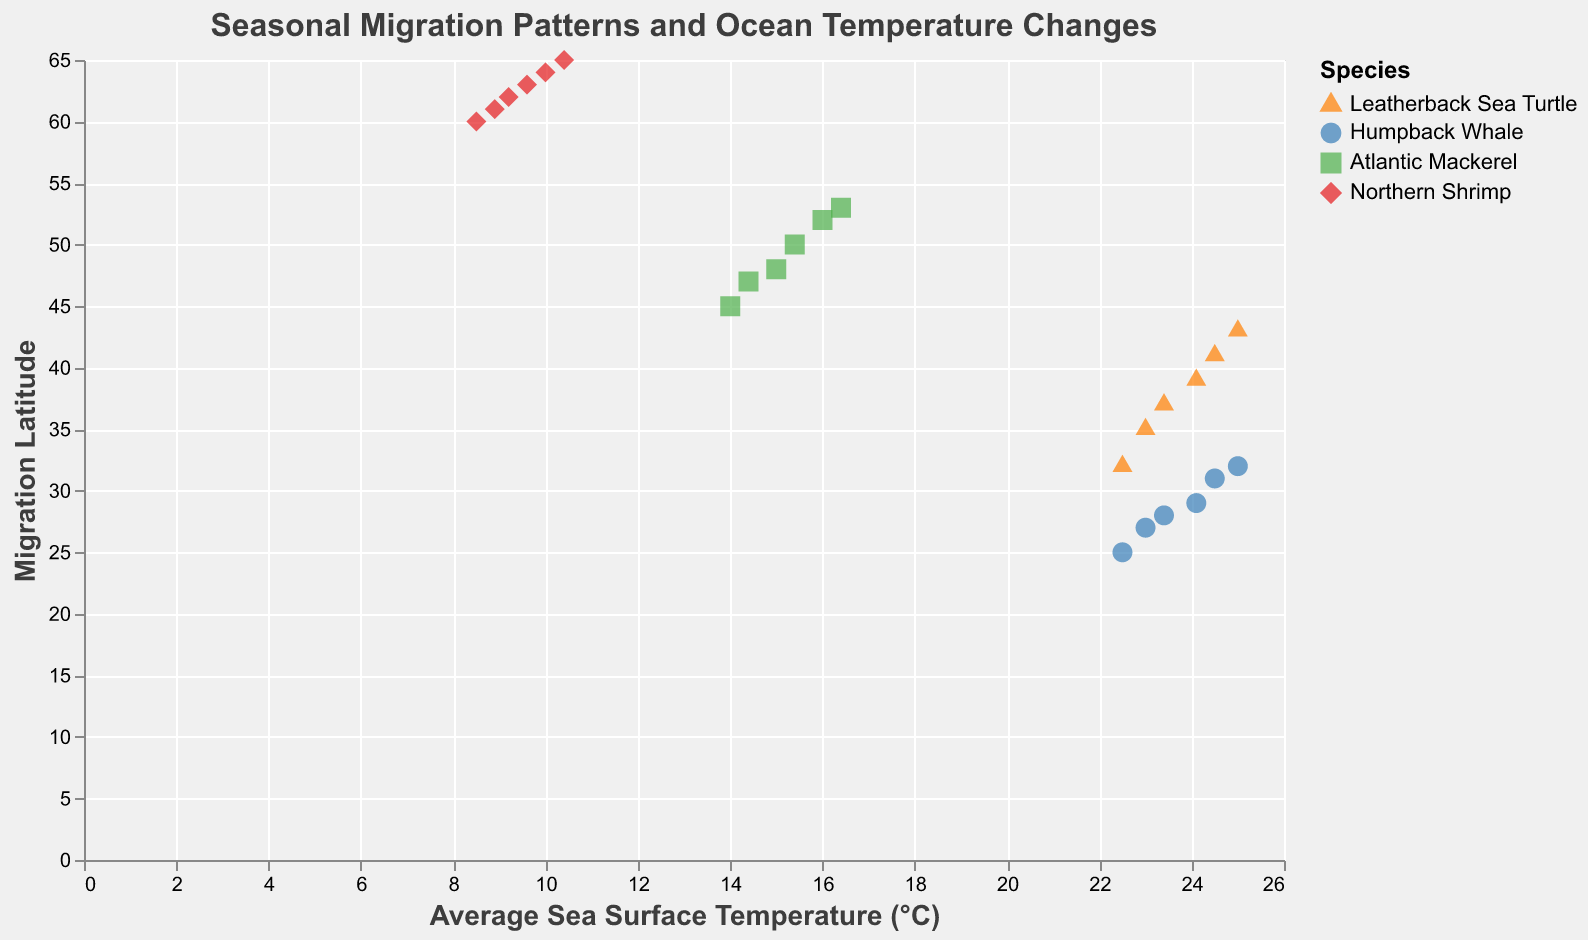What's the title of the figure? The title of the figure is displayed at the top and reads "Seasonal Migration Patterns and Ocean Temperature Changes".
Answer: Seasonal Migration Patterns and Ocean Temperature Changes Which species has the migration latitude furthest north in the data set? By observing the y-axis, which represents migration latitude, Northern Shrimp has the highest migration latitude around 60 to 65 degrees.
Answer: Northern Shrimp Which species shows the steepest increase in migration latitude with increasing sea surface temperature? By observing the slopes of trend lines on the scatter plot, the Leatherback Sea Turtle shows the steepest line, indicating a rapid increase in migration latitude with sea temperature.
Answer: Leatherback Sea Turtle What has been the change in migration latitude for the Atlantic Mackerel from 2000 to 2005? The migration latitude of the Atlantic Mackerel in 2000 is 45 and 53 in 2005. The change can be calculated as 53 - 45.
Answer: 8 degrees At what average sea surface temperature does the Humpback Whale's migration latitude reach around 29 degrees? By looking at the figure, the migration latitude of 29 degrees for Humpback Whale corresponds to approximately 24.1°C.
Answer: 24.1°C Which species shows the least change in migration latitude with increasing sea temperature? By comparing the slopes of trend lines, the Northern Shrimp's line is least steep, showing minimal change in latitude with temperature changes.
Answer: Northern Shrimp Which species data points cover the smallest range of average sea surface temperatures? Inspect the x-axis range of each species. Northern Shrimp data points span 8.5°C to 10.4°C, the smallest range.
Answer: Northern Shrimp Compare the migration latitudes of Leatherback Sea Turtle and Humpback Whale for the year 2000. Which one starts further north? For the year 2000, Leatherback Sea Turtle has a migration latitude of 32, and Humpback Whale has 25. Thus, Leatherback Sea Turtle starts further north.
Answer: Leatherback Sea Turtle Does any species appear to have a migration latitude that is more stable relative to the others? By analyzing the scatter plot and trend lines, the Northern Shrimp has a flatter trend line, indicating more stable migration latitudes.
Answer: Northern Shrimp What is the average migration latitude for the Humpback Whale over the entire period? The migration latitudes for Humpback Whale are 25, 27, 28, 29, 31, 32. Sum these values and divide by 6 to find the average: (25+27+28+29+31+32)/6.
Answer: 28.67 